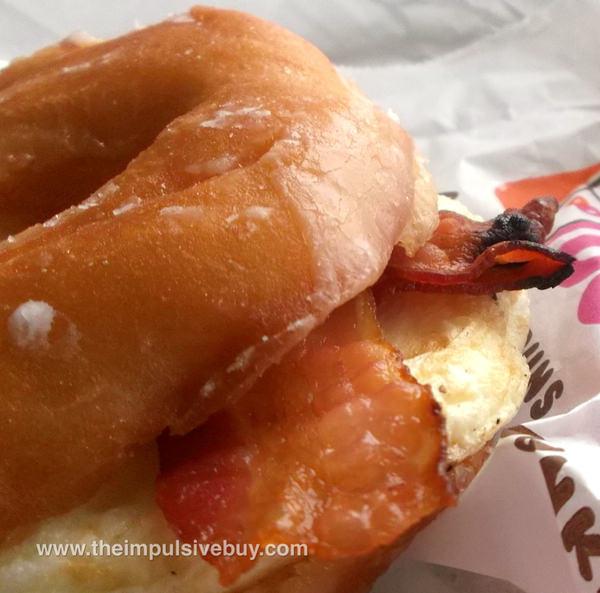Are these creme-filled donuts?
Be succinct. No. How many donuts are in the plate?
Keep it brief. 2. Is this a healthy snack?
Concise answer only. No. 